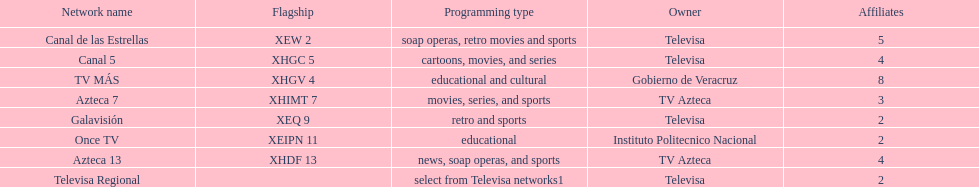How many networks display soap operas? 2. 